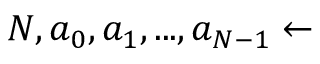Convert formula to latex. <formula><loc_0><loc_0><loc_500><loc_500>N , a _ { 0 } , a _ { 1 } , \dots , a _ { N - 1 } \gets</formula> 